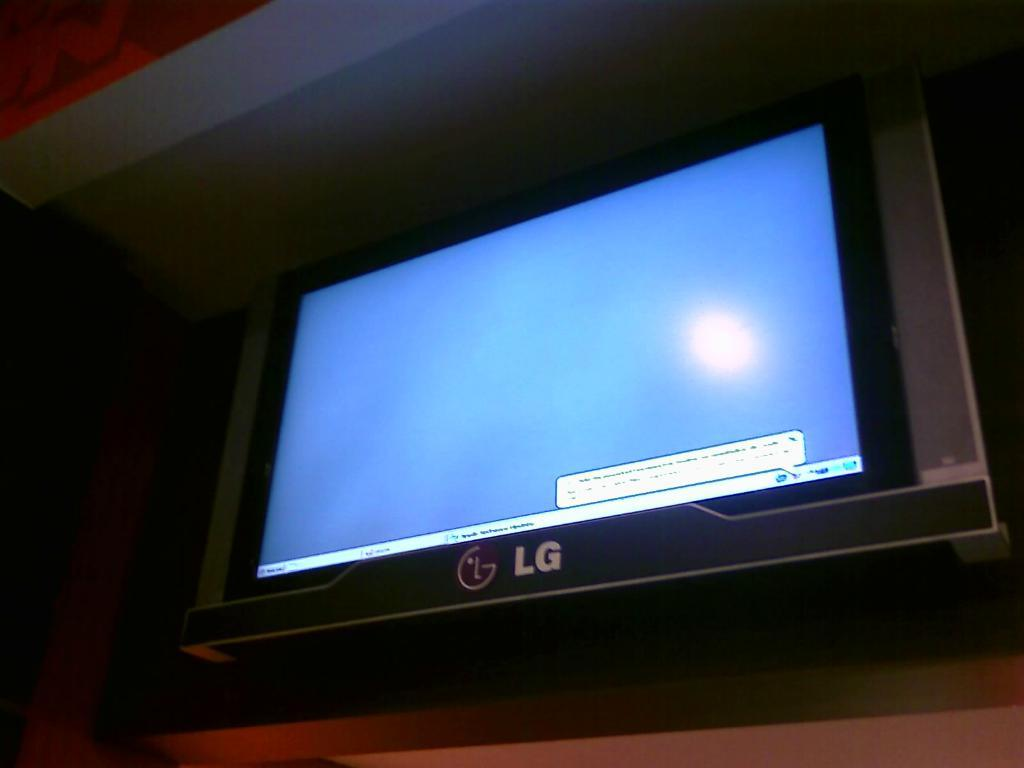<image>
Describe the image concisely. An LG branded monitor is showing the Microsoft Windows desktop screen. 